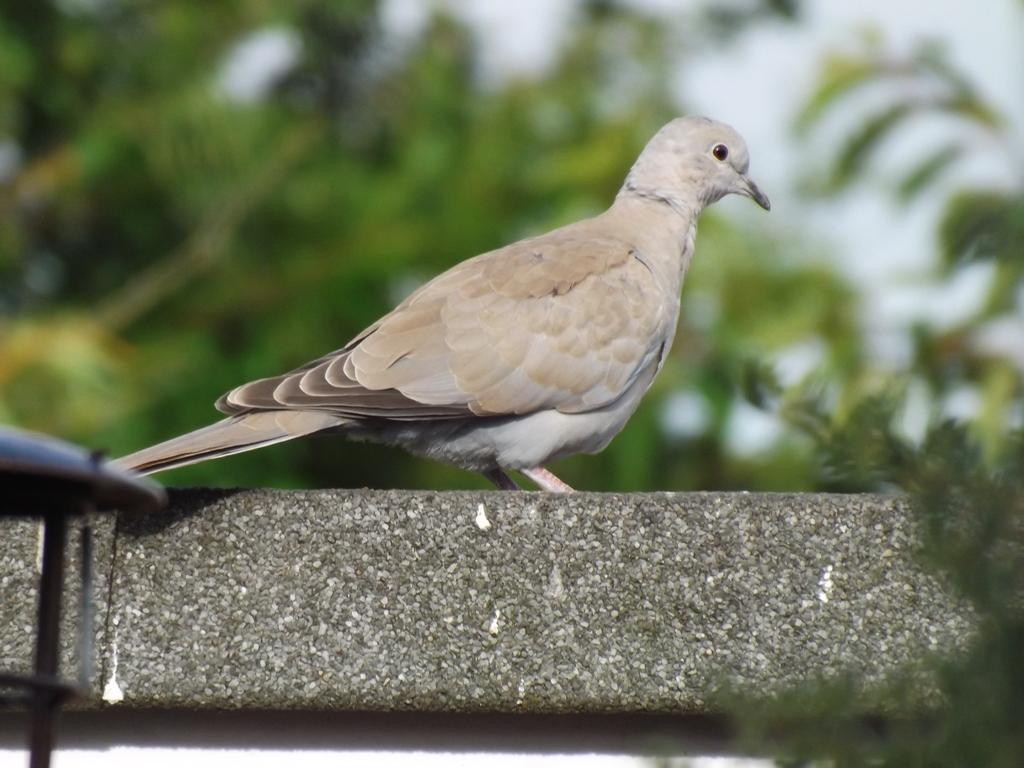What type of animal is in the image? There is a bird in the image. Can you describe the bird's coloring? The bird has white, cream, and brown colors. What can be seen in the background of the image? There are plants and the sky visible in the background of the image. What color are the plants? The plants are green. What color is the sky in the image? The sky has a white color. Where is the lock located on the bird in the image? There is no lock present on the bird in the image. Can you tell me how many bears are visible in the image? There are no bears present in the image. 